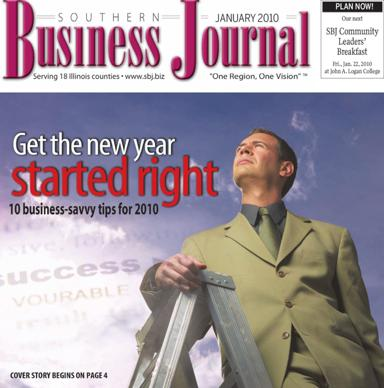Can you tell more about the 'One Region, One Vision' slogan seen on the magazine cover? 'One Region, One Vision' is a slogan that encapsulates a collective goal of unity and shared aspirations among the communities served by the Southern Business Journal. This theme likely promotes regional cooperation and holistic success, aimed at encouraging readers to think regionally for broader impacts. 